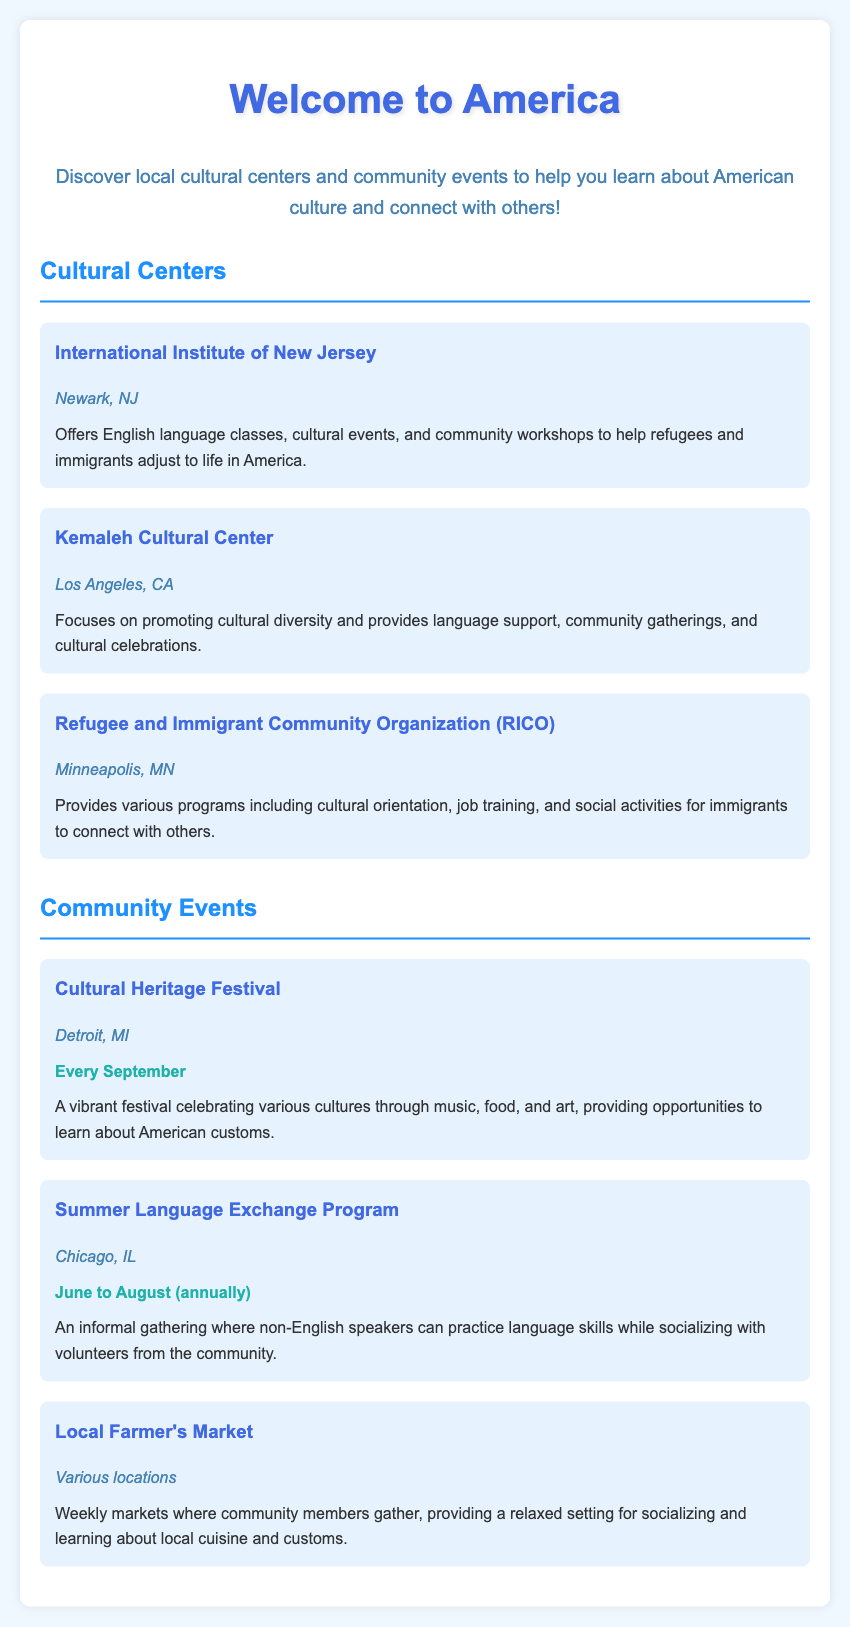what is the name of a cultural center in Newark, NJ? The document mentions the "International Institute of New Jersey" as a cultural center located in Newark, NJ.
Answer: International Institute of New Jersey what event occurs every September? The document states that the "Cultural Heritage Festival" takes place every September.
Answer: Cultural Heritage Festival which cultural center focuses on language support and community gatherings? The "Kemaleh Cultural Center" is described as one that provides language support and community gatherings.
Answer: Kemaleh Cultural Center what is the location for the Summer Language Exchange Program? The document indicates that the Summer Language Exchange Program takes place in Chicago, IL.
Answer: Chicago, IL how often do the Local Farmer's Markets occur? The document states that Local Farmer's Markets are weekly events.
Answer: Weekly what type of event aims to help refugees and immigrants adjust to life in America? The cultural center "International Institute of New Jersey" offers programs that help refugees and immigrants adjust to life in America.
Answer: English language classes what activities does RICO provide? The Refugee and Immigrant Community Organization (RICO) provides programs including cultural orientation, job training, and social activities for immigrants.
Answer: Cultural orientation, job training, social activities what type of celebration is the Cultural Heritage Festival? The Cultural Heritage Festival is a vibrant festival celebrating various cultures through music, food, and art.
Answer: Vibrant festival what is the duration of the Summer Language Exchange Program? The event lasts from June to August, annually.
Answer: June to August (annually) 